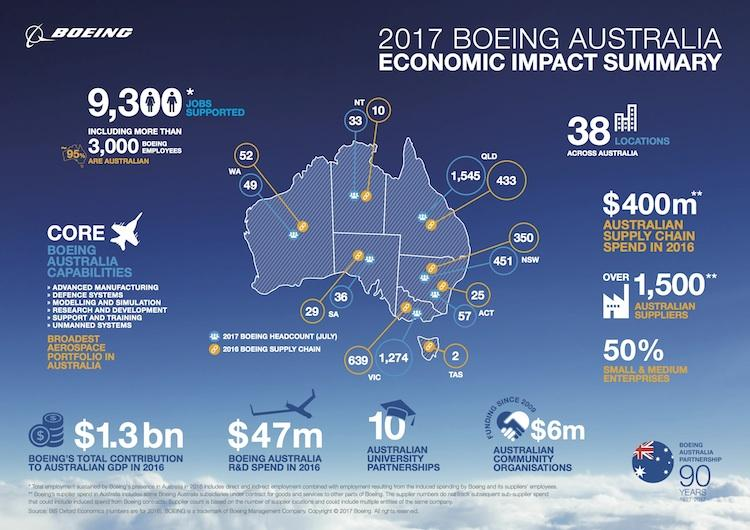Draw attention to some important aspects in this diagram. Queensland had the highest head count in 2017. The difference in headcount between New South Wales and the Australian Capital Territory is 394. 